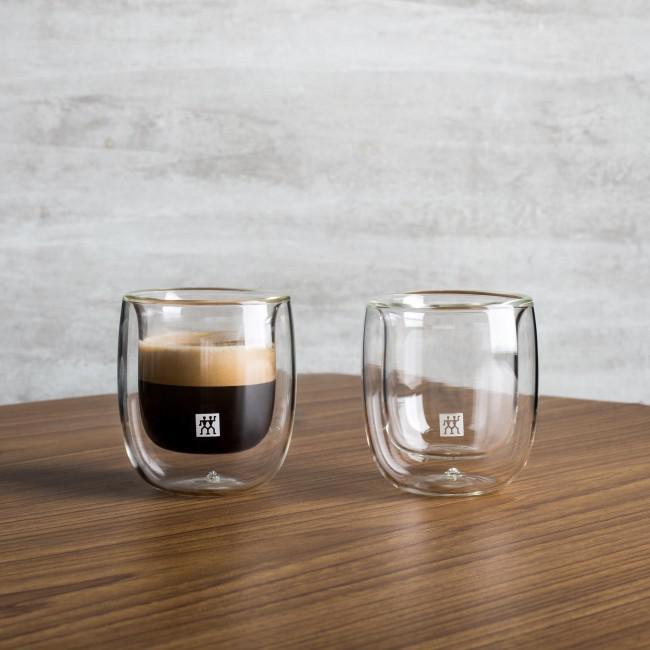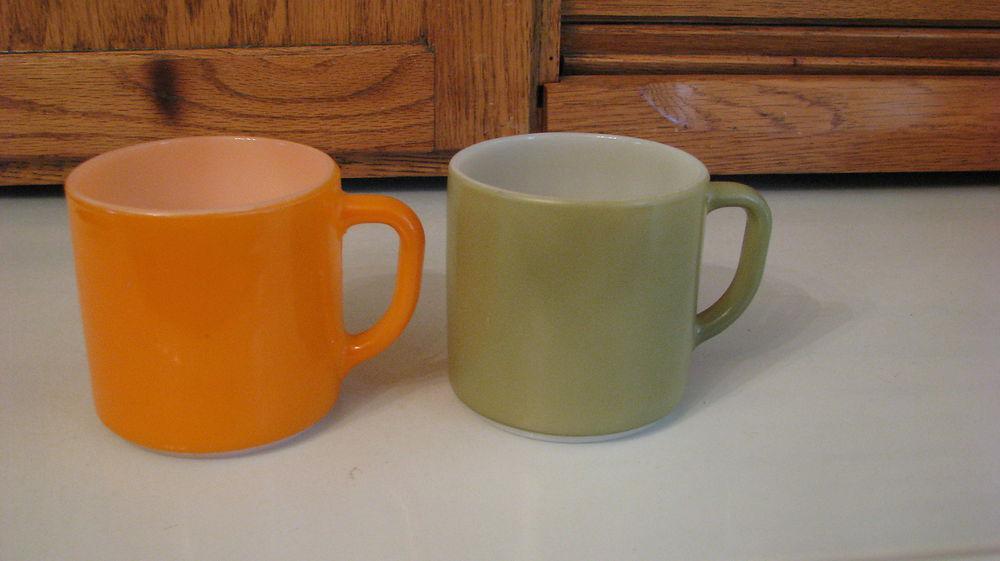The first image is the image on the left, the second image is the image on the right. For the images displayed, is the sentence "There are four tea cups sitting  on saucers." factually correct? Answer yes or no. No. The first image is the image on the left, the second image is the image on the right. Given the left and right images, does the statement "Left image shows two cups of the same beverages on white saucers." hold true? Answer yes or no. No. The first image is the image on the left, the second image is the image on the right. Given the left and right images, does the statement "One image appears to depict two completely empty cups." hold true? Answer yes or no. Yes. The first image is the image on the left, the second image is the image on the right. Assess this claim about the two images: "Two cups for hot drinks are in each image, each sitting on a matching saucer.". Correct or not? Answer yes or no. No. 